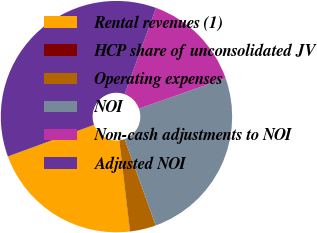Convert chart to OTSL. <chart><loc_0><loc_0><loc_500><loc_500><pie_chart><fcel>Rental revenues (1)<fcel>HCP share of unconsolidated JV<fcel>Operating expenses<fcel>NOI<fcel>Non-cash adjustments to NOI<fcel>Adjusted NOI<nl><fcel>21.26%<fcel>0.02%<fcel>3.64%<fcel>24.88%<fcel>14.04%<fcel>36.16%<nl></chart> 